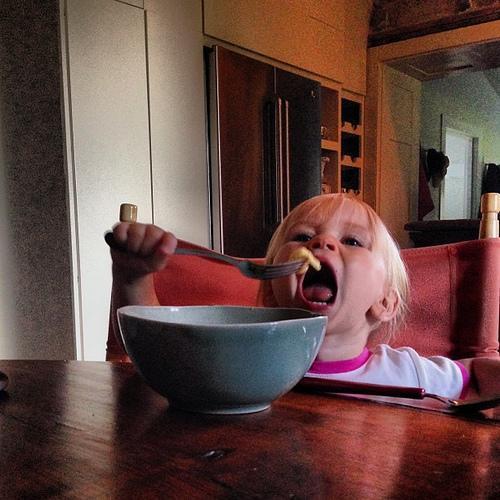How many kids are pictured?
Give a very brief answer. 1. 